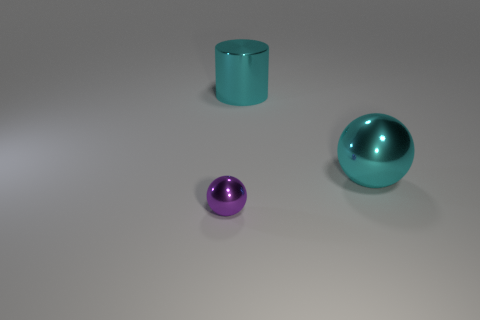Subtract all cyan spheres. How many spheres are left? 1 Add 3 cyan spheres. How many objects exist? 6 Subtract 1 cylinders. How many cylinders are left? 0 Subtract all cyan spheres. Subtract all cyan blocks. How many spheres are left? 1 Subtract all purple cylinders. How many purple spheres are left? 1 Subtract all large things. Subtract all purple shiny objects. How many objects are left? 0 Add 2 small spheres. How many small spheres are left? 3 Add 2 small purple metal things. How many small purple metal things exist? 3 Subtract 0 green balls. How many objects are left? 3 Subtract all spheres. How many objects are left? 1 